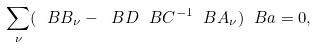<formula> <loc_0><loc_0><loc_500><loc_500>\sum _ { \nu } ( \ B B _ { \nu } - \ B D \ B C ^ { - 1 } \ B A _ { \nu } ) \ B a = 0 ,</formula> 